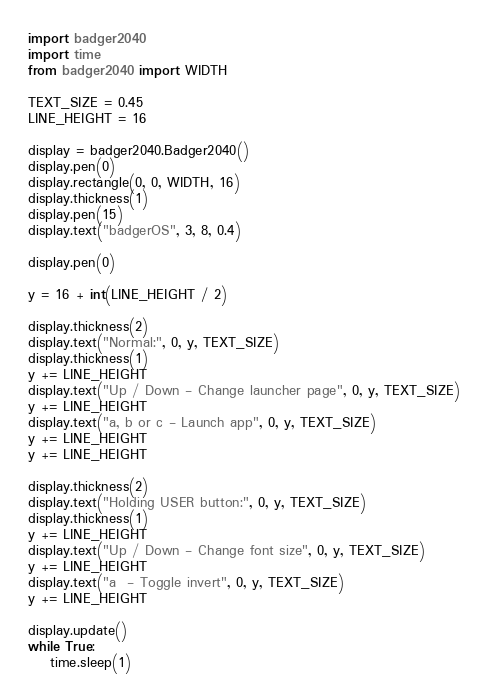<code> <loc_0><loc_0><loc_500><loc_500><_Python_>import badger2040
import time
from badger2040 import WIDTH

TEXT_SIZE = 0.45
LINE_HEIGHT = 16

display = badger2040.Badger2040()
display.pen(0)
display.rectangle(0, 0, WIDTH, 16)
display.thickness(1)
display.pen(15)
display.text("badgerOS", 3, 8, 0.4)

display.pen(0)

y = 16 + int(LINE_HEIGHT / 2)

display.thickness(2)
display.text("Normal:", 0, y, TEXT_SIZE)
display.thickness(1)
y += LINE_HEIGHT
display.text("Up / Down - Change launcher page", 0, y, TEXT_SIZE)
y += LINE_HEIGHT
display.text("a, b or c - Launch app", 0, y, TEXT_SIZE)
y += LINE_HEIGHT
y += LINE_HEIGHT

display.thickness(2)
display.text("Holding USER button:", 0, y, TEXT_SIZE)
display.thickness(1)
y += LINE_HEIGHT
display.text("Up / Down - Change font size", 0, y, TEXT_SIZE)
y += LINE_HEIGHT
display.text("a  - Toggle invert", 0, y, TEXT_SIZE)
y += LINE_HEIGHT

display.update()
while True:
    time.sleep(1)
</code> 